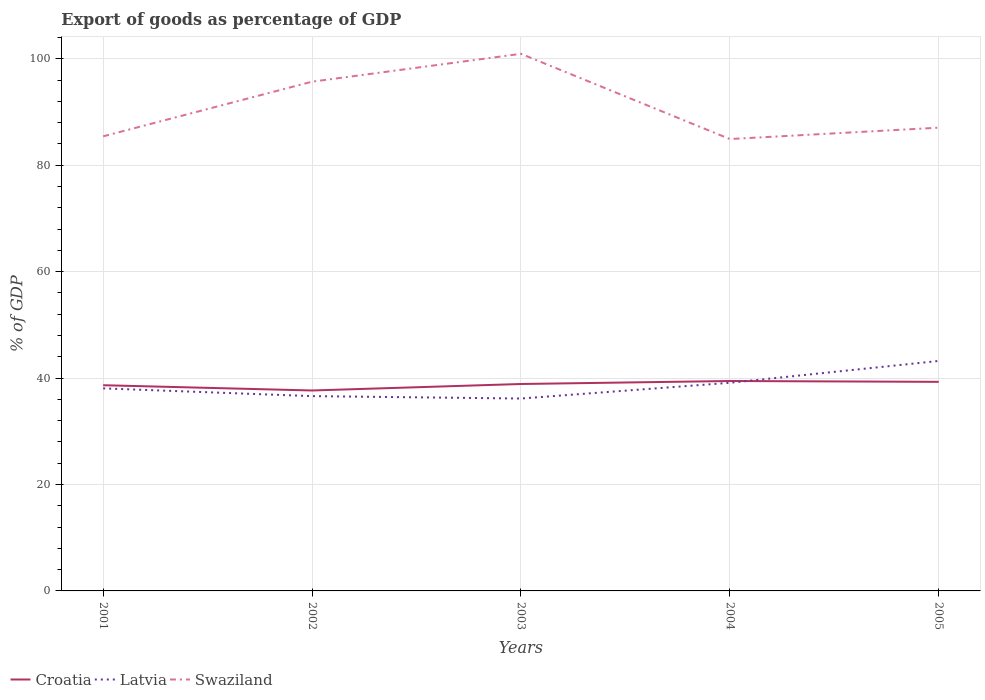Is the number of lines equal to the number of legend labels?
Provide a succinct answer. Yes. Across all years, what is the maximum export of goods as percentage of GDP in Latvia?
Offer a terse response. 36.16. What is the total export of goods as percentage of GDP in Swaziland in the graph?
Your answer should be compact. -2.14. What is the difference between the highest and the second highest export of goods as percentage of GDP in Croatia?
Your answer should be compact. 1.78. Is the export of goods as percentage of GDP in Swaziland strictly greater than the export of goods as percentage of GDP in Latvia over the years?
Provide a succinct answer. No. How many years are there in the graph?
Offer a very short reply. 5. What is the difference between two consecutive major ticks on the Y-axis?
Your answer should be compact. 20. Are the values on the major ticks of Y-axis written in scientific E-notation?
Your answer should be compact. No. Does the graph contain any zero values?
Your response must be concise. No. Does the graph contain grids?
Your answer should be very brief. Yes. How are the legend labels stacked?
Your answer should be compact. Horizontal. What is the title of the graph?
Your answer should be compact. Export of goods as percentage of GDP. Does "Guinea" appear as one of the legend labels in the graph?
Give a very brief answer. No. What is the label or title of the X-axis?
Offer a very short reply. Years. What is the label or title of the Y-axis?
Offer a very short reply. % of GDP. What is the % of GDP in Croatia in 2001?
Offer a terse response. 38.66. What is the % of GDP in Latvia in 2001?
Offer a terse response. 38.07. What is the % of GDP of Swaziland in 2001?
Ensure brevity in your answer.  85.44. What is the % of GDP of Croatia in 2002?
Provide a succinct answer. 37.67. What is the % of GDP of Latvia in 2002?
Offer a terse response. 36.61. What is the % of GDP in Swaziland in 2002?
Your response must be concise. 95.71. What is the % of GDP of Croatia in 2003?
Offer a terse response. 38.89. What is the % of GDP of Latvia in 2003?
Your answer should be very brief. 36.16. What is the % of GDP in Swaziland in 2003?
Your response must be concise. 100.95. What is the % of GDP of Croatia in 2004?
Provide a succinct answer. 39.45. What is the % of GDP in Latvia in 2004?
Your response must be concise. 39.12. What is the % of GDP in Swaziland in 2004?
Make the answer very short. 84.93. What is the % of GDP of Croatia in 2005?
Give a very brief answer. 39.3. What is the % of GDP of Latvia in 2005?
Provide a succinct answer. 43.22. What is the % of GDP of Swaziland in 2005?
Your answer should be very brief. 87.07. Across all years, what is the maximum % of GDP of Croatia?
Offer a very short reply. 39.45. Across all years, what is the maximum % of GDP in Latvia?
Your answer should be compact. 43.22. Across all years, what is the maximum % of GDP of Swaziland?
Make the answer very short. 100.95. Across all years, what is the minimum % of GDP of Croatia?
Provide a succinct answer. 37.67. Across all years, what is the minimum % of GDP in Latvia?
Keep it short and to the point. 36.16. Across all years, what is the minimum % of GDP of Swaziland?
Offer a very short reply. 84.93. What is the total % of GDP of Croatia in the graph?
Your answer should be compact. 193.97. What is the total % of GDP in Latvia in the graph?
Provide a short and direct response. 193.19. What is the total % of GDP of Swaziland in the graph?
Provide a short and direct response. 454.1. What is the difference between the % of GDP in Croatia in 2001 and that in 2002?
Your answer should be very brief. 0.99. What is the difference between the % of GDP in Latvia in 2001 and that in 2002?
Offer a very short reply. 1.46. What is the difference between the % of GDP of Swaziland in 2001 and that in 2002?
Offer a very short reply. -10.27. What is the difference between the % of GDP of Croatia in 2001 and that in 2003?
Make the answer very short. -0.23. What is the difference between the % of GDP in Latvia in 2001 and that in 2003?
Keep it short and to the point. 1.91. What is the difference between the % of GDP of Swaziland in 2001 and that in 2003?
Provide a succinct answer. -15.51. What is the difference between the % of GDP in Croatia in 2001 and that in 2004?
Make the answer very short. -0.79. What is the difference between the % of GDP of Latvia in 2001 and that in 2004?
Offer a very short reply. -1.05. What is the difference between the % of GDP in Swaziland in 2001 and that in 2004?
Provide a short and direct response. 0.51. What is the difference between the % of GDP of Croatia in 2001 and that in 2005?
Provide a short and direct response. -0.63. What is the difference between the % of GDP in Latvia in 2001 and that in 2005?
Give a very brief answer. -5.16. What is the difference between the % of GDP in Swaziland in 2001 and that in 2005?
Keep it short and to the point. -1.63. What is the difference between the % of GDP of Croatia in 2002 and that in 2003?
Offer a terse response. -1.22. What is the difference between the % of GDP of Latvia in 2002 and that in 2003?
Provide a short and direct response. 0.45. What is the difference between the % of GDP of Swaziland in 2002 and that in 2003?
Provide a succinct answer. -5.24. What is the difference between the % of GDP of Croatia in 2002 and that in 2004?
Your answer should be very brief. -1.78. What is the difference between the % of GDP of Latvia in 2002 and that in 2004?
Your answer should be compact. -2.51. What is the difference between the % of GDP in Swaziland in 2002 and that in 2004?
Offer a very short reply. 10.78. What is the difference between the % of GDP in Croatia in 2002 and that in 2005?
Keep it short and to the point. -1.62. What is the difference between the % of GDP in Latvia in 2002 and that in 2005?
Offer a very short reply. -6.61. What is the difference between the % of GDP of Swaziland in 2002 and that in 2005?
Offer a terse response. 8.64. What is the difference between the % of GDP in Croatia in 2003 and that in 2004?
Your answer should be very brief. -0.56. What is the difference between the % of GDP in Latvia in 2003 and that in 2004?
Your answer should be compact. -2.96. What is the difference between the % of GDP of Swaziland in 2003 and that in 2004?
Offer a very short reply. 16.02. What is the difference between the % of GDP of Croatia in 2003 and that in 2005?
Provide a succinct answer. -0.41. What is the difference between the % of GDP in Latvia in 2003 and that in 2005?
Give a very brief answer. -7.06. What is the difference between the % of GDP of Swaziland in 2003 and that in 2005?
Your answer should be very brief. 13.88. What is the difference between the % of GDP in Croatia in 2004 and that in 2005?
Provide a short and direct response. 0.16. What is the difference between the % of GDP of Latvia in 2004 and that in 2005?
Offer a very short reply. -4.11. What is the difference between the % of GDP of Swaziland in 2004 and that in 2005?
Ensure brevity in your answer.  -2.14. What is the difference between the % of GDP of Croatia in 2001 and the % of GDP of Latvia in 2002?
Ensure brevity in your answer.  2.05. What is the difference between the % of GDP in Croatia in 2001 and the % of GDP in Swaziland in 2002?
Your answer should be compact. -57.05. What is the difference between the % of GDP of Latvia in 2001 and the % of GDP of Swaziland in 2002?
Provide a short and direct response. -57.64. What is the difference between the % of GDP in Croatia in 2001 and the % of GDP in Latvia in 2003?
Your answer should be very brief. 2.5. What is the difference between the % of GDP in Croatia in 2001 and the % of GDP in Swaziland in 2003?
Keep it short and to the point. -62.29. What is the difference between the % of GDP in Latvia in 2001 and the % of GDP in Swaziland in 2003?
Ensure brevity in your answer.  -62.88. What is the difference between the % of GDP in Croatia in 2001 and the % of GDP in Latvia in 2004?
Offer a terse response. -0.46. What is the difference between the % of GDP of Croatia in 2001 and the % of GDP of Swaziland in 2004?
Keep it short and to the point. -46.27. What is the difference between the % of GDP of Latvia in 2001 and the % of GDP of Swaziland in 2004?
Your response must be concise. -46.86. What is the difference between the % of GDP of Croatia in 2001 and the % of GDP of Latvia in 2005?
Provide a succinct answer. -4.56. What is the difference between the % of GDP of Croatia in 2001 and the % of GDP of Swaziland in 2005?
Your answer should be very brief. -48.4. What is the difference between the % of GDP of Latvia in 2001 and the % of GDP of Swaziland in 2005?
Ensure brevity in your answer.  -49. What is the difference between the % of GDP of Croatia in 2002 and the % of GDP of Latvia in 2003?
Offer a very short reply. 1.51. What is the difference between the % of GDP in Croatia in 2002 and the % of GDP in Swaziland in 2003?
Provide a succinct answer. -63.28. What is the difference between the % of GDP in Latvia in 2002 and the % of GDP in Swaziland in 2003?
Your response must be concise. -64.34. What is the difference between the % of GDP of Croatia in 2002 and the % of GDP of Latvia in 2004?
Provide a short and direct response. -1.45. What is the difference between the % of GDP of Croatia in 2002 and the % of GDP of Swaziland in 2004?
Offer a very short reply. -47.26. What is the difference between the % of GDP in Latvia in 2002 and the % of GDP in Swaziland in 2004?
Make the answer very short. -48.32. What is the difference between the % of GDP of Croatia in 2002 and the % of GDP of Latvia in 2005?
Offer a very short reply. -5.55. What is the difference between the % of GDP in Croatia in 2002 and the % of GDP in Swaziland in 2005?
Offer a very short reply. -49.4. What is the difference between the % of GDP of Latvia in 2002 and the % of GDP of Swaziland in 2005?
Keep it short and to the point. -50.45. What is the difference between the % of GDP of Croatia in 2003 and the % of GDP of Latvia in 2004?
Offer a very short reply. -0.23. What is the difference between the % of GDP of Croatia in 2003 and the % of GDP of Swaziland in 2004?
Keep it short and to the point. -46.04. What is the difference between the % of GDP of Latvia in 2003 and the % of GDP of Swaziland in 2004?
Your response must be concise. -48.77. What is the difference between the % of GDP of Croatia in 2003 and the % of GDP of Latvia in 2005?
Your answer should be very brief. -4.33. What is the difference between the % of GDP in Croatia in 2003 and the % of GDP in Swaziland in 2005?
Make the answer very short. -48.18. What is the difference between the % of GDP of Latvia in 2003 and the % of GDP of Swaziland in 2005?
Offer a very short reply. -50.91. What is the difference between the % of GDP of Croatia in 2004 and the % of GDP of Latvia in 2005?
Provide a short and direct response. -3.77. What is the difference between the % of GDP of Croatia in 2004 and the % of GDP of Swaziland in 2005?
Offer a very short reply. -47.61. What is the difference between the % of GDP of Latvia in 2004 and the % of GDP of Swaziland in 2005?
Offer a very short reply. -47.95. What is the average % of GDP in Croatia per year?
Ensure brevity in your answer.  38.79. What is the average % of GDP of Latvia per year?
Your answer should be very brief. 38.64. What is the average % of GDP in Swaziland per year?
Give a very brief answer. 90.82. In the year 2001, what is the difference between the % of GDP in Croatia and % of GDP in Latvia?
Provide a succinct answer. 0.59. In the year 2001, what is the difference between the % of GDP in Croatia and % of GDP in Swaziland?
Keep it short and to the point. -46.78. In the year 2001, what is the difference between the % of GDP of Latvia and % of GDP of Swaziland?
Keep it short and to the point. -47.37. In the year 2002, what is the difference between the % of GDP in Croatia and % of GDP in Latvia?
Offer a very short reply. 1.06. In the year 2002, what is the difference between the % of GDP of Croatia and % of GDP of Swaziland?
Make the answer very short. -58.04. In the year 2002, what is the difference between the % of GDP of Latvia and % of GDP of Swaziland?
Offer a terse response. -59.1. In the year 2003, what is the difference between the % of GDP in Croatia and % of GDP in Latvia?
Ensure brevity in your answer.  2.73. In the year 2003, what is the difference between the % of GDP of Croatia and % of GDP of Swaziland?
Offer a very short reply. -62.06. In the year 2003, what is the difference between the % of GDP in Latvia and % of GDP in Swaziland?
Ensure brevity in your answer.  -64.79. In the year 2004, what is the difference between the % of GDP of Croatia and % of GDP of Latvia?
Ensure brevity in your answer.  0.34. In the year 2004, what is the difference between the % of GDP of Croatia and % of GDP of Swaziland?
Make the answer very short. -45.48. In the year 2004, what is the difference between the % of GDP in Latvia and % of GDP in Swaziland?
Offer a terse response. -45.81. In the year 2005, what is the difference between the % of GDP in Croatia and % of GDP in Latvia?
Provide a short and direct response. -3.93. In the year 2005, what is the difference between the % of GDP in Croatia and % of GDP in Swaziland?
Provide a succinct answer. -47.77. In the year 2005, what is the difference between the % of GDP in Latvia and % of GDP in Swaziland?
Ensure brevity in your answer.  -43.84. What is the ratio of the % of GDP of Croatia in 2001 to that in 2002?
Make the answer very short. 1.03. What is the ratio of the % of GDP in Latvia in 2001 to that in 2002?
Provide a short and direct response. 1.04. What is the ratio of the % of GDP in Swaziland in 2001 to that in 2002?
Keep it short and to the point. 0.89. What is the ratio of the % of GDP of Latvia in 2001 to that in 2003?
Provide a short and direct response. 1.05. What is the ratio of the % of GDP of Swaziland in 2001 to that in 2003?
Give a very brief answer. 0.85. What is the ratio of the % of GDP of Croatia in 2001 to that in 2004?
Offer a very short reply. 0.98. What is the ratio of the % of GDP of Latvia in 2001 to that in 2004?
Offer a terse response. 0.97. What is the ratio of the % of GDP of Croatia in 2001 to that in 2005?
Your answer should be compact. 0.98. What is the ratio of the % of GDP of Latvia in 2001 to that in 2005?
Provide a succinct answer. 0.88. What is the ratio of the % of GDP of Swaziland in 2001 to that in 2005?
Your answer should be compact. 0.98. What is the ratio of the % of GDP of Croatia in 2002 to that in 2003?
Your response must be concise. 0.97. What is the ratio of the % of GDP of Latvia in 2002 to that in 2003?
Your answer should be very brief. 1.01. What is the ratio of the % of GDP of Swaziland in 2002 to that in 2003?
Keep it short and to the point. 0.95. What is the ratio of the % of GDP in Croatia in 2002 to that in 2004?
Offer a very short reply. 0.95. What is the ratio of the % of GDP in Latvia in 2002 to that in 2004?
Give a very brief answer. 0.94. What is the ratio of the % of GDP in Swaziland in 2002 to that in 2004?
Your response must be concise. 1.13. What is the ratio of the % of GDP of Croatia in 2002 to that in 2005?
Your answer should be very brief. 0.96. What is the ratio of the % of GDP in Latvia in 2002 to that in 2005?
Your answer should be very brief. 0.85. What is the ratio of the % of GDP in Swaziland in 2002 to that in 2005?
Your answer should be very brief. 1.1. What is the ratio of the % of GDP of Croatia in 2003 to that in 2004?
Make the answer very short. 0.99. What is the ratio of the % of GDP of Latvia in 2003 to that in 2004?
Offer a very short reply. 0.92. What is the ratio of the % of GDP in Swaziland in 2003 to that in 2004?
Make the answer very short. 1.19. What is the ratio of the % of GDP of Latvia in 2003 to that in 2005?
Ensure brevity in your answer.  0.84. What is the ratio of the % of GDP of Swaziland in 2003 to that in 2005?
Provide a short and direct response. 1.16. What is the ratio of the % of GDP in Croatia in 2004 to that in 2005?
Offer a terse response. 1. What is the ratio of the % of GDP in Latvia in 2004 to that in 2005?
Your answer should be very brief. 0.91. What is the ratio of the % of GDP of Swaziland in 2004 to that in 2005?
Make the answer very short. 0.98. What is the difference between the highest and the second highest % of GDP of Croatia?
Provide a short and direct response. 0.16. What is the difference between the highest and the second highest % of GDP of Latvia?
Ensure brevity in your answer.  4.11. What is the difference between the highest and the second highest % of GDP in Swaziland?
Give a very brief answer. 5.24. What is the difference between the highest and the lowest % of GDP in Croatia?
Keep it short and to the point. 1.78. What is the difference between the highest and the lowest % of GDP in Latvia?
Keep it short and to the point. 7.06. What is the difference between the highest and the lowest % of GDP in Swaziland?
Your response must be concise. 16.02. 